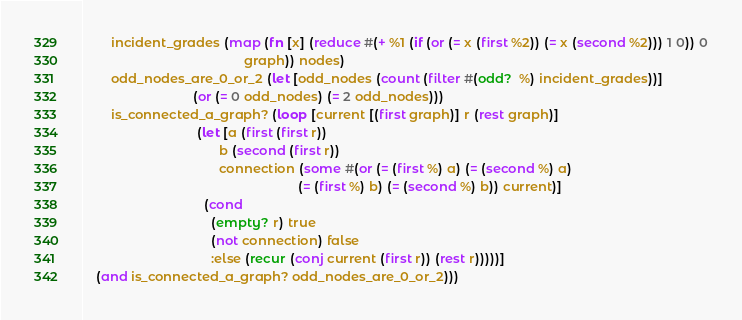Convert code to text. <code><loc_0><loc_0><loc_500><loc_500><_Clojure_>        incident_grades (map (fn [x] (reduce #(+ %1 (if (or (= x (first %2)) (= x (second %2))) 1 0)) 0
                                             graph)) nodes)
        odd_nodes_are_0_or_2 (let [odd_nodes (count (filter #(odd?  %) incident_grades))]
                               (or (= 0 odd_nodes) (= 2 odd_nodes)))
        is_connected_a_graph? (loop [current [(first graph)] r (rest graph)]
                                (let [a (first (first r)) 
                                      b (second (first r))
                                      connection (some #(or (= (first %) a) (= (second %) a)
                                                            (= (first %) b) (= (second %) b)) current)]
                                  (cond 
                                    (empty? r) true
                                    (not connection) false
                                    :else (recur (conj current (first r)) (rest r)))))]
    (and is_connected_a_graph? odd_nodes_are_0_or_2)))</code> 